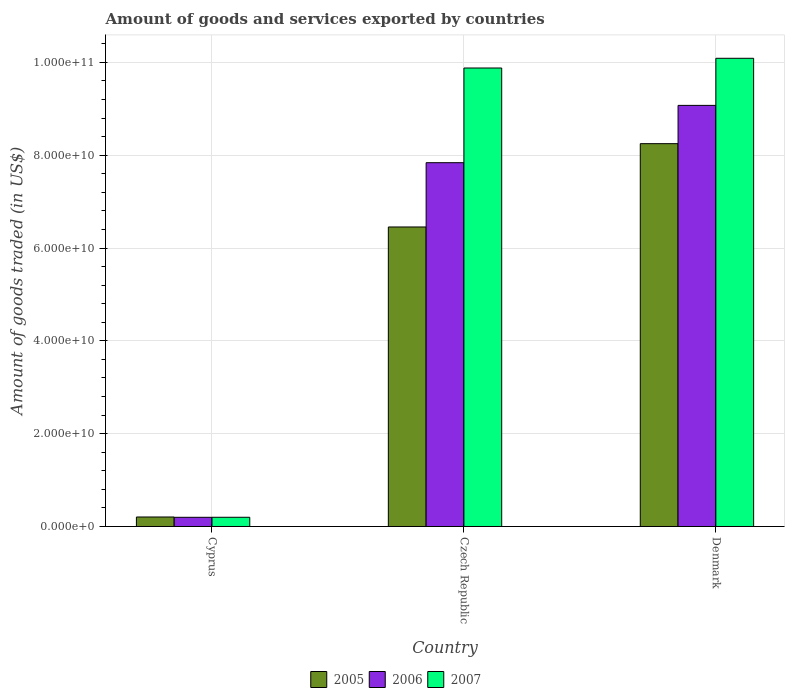How many different coloured bars are there?
Provide a succinct answer. 3. How many groups of bars are there?
Give a very brief answer. 3. Are the number of bars on each tick of the X-axis equal?
Ensure brevity in your answer.  Yes. How many bars are there on the 2nd tick from the left?
Give a very brief answer. 3. In how many cases, is the number of bars for a given country not equal to the number of legend labels?
Your answer should be very brief. 0. What is the total amount of goods and services exported in 2007 in Cyprus?
Offer a terse response. 1.99e+09. Across all countries, what is the maximum total amount of goods and services exported in 2006?
Keep it short and to the point. 9.07e+1. Across all countries, what is the minimum total amount of goods and services exported in 2006?
Provide a succinct answer. 1.98e+09. In which country was the total amount of goods and services exported in 2007 minimum?
Provide a succinct answer. Cyprus. What is the total total amount of goods and services exported in 2006 in the graph?
Offer a terse response. 1.71e+11. What is the difference between the total amount of goods and services exported in 2006 in Cyprus and that in Czech Republic?
Offer a very short reply. -7.64e+1. What is the difference between the total amount of goods and services exported in 2005 in Denmark and the total amount of goods and services exported in 2007 in Czech Republic?
Make the answer very short. -1.63e+1. What is the average total amount of goods and services exported in 2007 per country?
Your answer should be very brief. 6.72e+1. What is the difference between the total amount of goods and services exported of/in 2006 and total amount of goods and services exported of/in 2007 in Cyprus?
Provide a short and direct response. -7.27e+06. What is the ratio of the total amount of goods and services exported in 2007 in Czech Republic to that in Denmark?
Your response must be concise. 0.98. Is the difference between the total amount of goods and services exported in 2006 in Cyprus and Denmark greater than the difference between the total amount of goods and services exported in 2007 in Cyprus and Denmark?
Make the answer very short. Yes. What is the difference between the highest and the second highest total amount of goods and services exported in 2006?
Offer a terse response. -1.23e+1. What is the difference between the highest and the lowest total amount of goods and services exported in 2005?
Provide a succinct answer. 8.04e+1. Is it the case that in every country, the sum of the total amount of goods and services exported in 2006 and total amount of goods and services exported in 2007 is greater than the total amount of goods and services exported in 2005?
Keep it short and to the point. Yes. Are all the bars in the graph horizontal?
Your answer should be compact. No. What is the difference between two consecutive major ticks on the Y-axis?
Offer a very short reply. 2.00e+1. Does the graph contain any zero values?
Your answer should be very brief. No. Does the graph contain grids?
Provide a short and direct response. Yes. Where does the legend appear in the graph?
Make the answer very short. Bottom center. How many legend labels are there?
Your answer should be compact. 3. What is the title of the graph?
Your response must be concise. Amount of goods and services exported by countries. What is the label or title of the X-axis?
Offer a very short reply. Country. What is the label or title of the Y-axis?
Make the answer very short. Amount of goods traded (in US$). What is the Amount of goods traded (in US$) of 2005 in Cyprus?
Keep it short and to the point. 2.05e+09. What is the Amount of goods traded (in US$) in 2006 in Cyprus?
Offer a very short reply. 1.98e+09. What is the Amount of goods traded (in US$) in 2007 in Cyprus?
Provide a short and direct response. 1.99e+09. What is the Amount of goods traded (in US$) in 2005 in Czech Republic?
Your answer should be very brief. 6.45e+1. What is the Amount of goods traded (in US$) of 2006 in Czech Republic?
Keep it short and to the point. 7.84e+1. What is the Amount of goods traded (in US$) in 2007 in Czech Republic?
Your answer should be compact. 9.88e+1. What is the Amount of goods traded (in US$) in 2005 in Denmark?
Give a very brief answer. 8.25e+1. What is the Amount of goods traded (in US$) in 2006 in Denmark?
Make the answer very short. 9.07e+1. What is the Amount of goods traded (in US$) of 2007 in Denmark?
Offer a terse response. 1.01e+11. Across all countries, what is the maximum Amount of goods traded (in US$) in 2005?
Your answer should be very brief. 8.25e+1. Across all countries, what is the maximum Amount of goods traded (in US$) in 2006?
Your response must be concise. 9.07e+1. Across all countries, what is the maximum Amount of goods traded (in US$) in 2007?
Make the answer very short. 1.01e+11. Across all countries, what is the minimum Amount of goods traded (in US$) in 2005?
Make the answer very short. 2.05e+09. Across all countries, what is the minimum Amount of goods traded (in US$) of 2006?
Make the answer very short. 1.98e+09. Across all countries, what is the minimum Amount of goods traded (in US$) in 2007?
Offer a terse response. 1.99e+09. What is the total Amount of goods traded (in US$) in 2005 in the graph?
Offer a very short reply. 1.49e+11. What is the total Amount of goods traded (in US$) in 2006 in the graph?
Your answer should be compact. 1.71e+11. What is the total Amount of goods traded (in US$) of 2007 in the graph?
Offer a very short reply. 2.02e+11. What is the difference between the Amount of goods traded (in US$) in 2005 in Cyprus and that in Czech Republic?
Your response must be concise. -6.25e+1. What is the difference between the Amount of goods traded (in US$) in 2006 in Cyprus and that in Czech Republic?
Ensure brevity in your answer.  -7.64e+1. What is the difference between the Amount of goods traded (in US$) in 2007 in Cyprus and that in Czech Republic?
Ensure brevity in your answer.  -9.68e+1. What is the difference between the Amount of goods traded (in US$) of 2005 in Cyprus and that in Denmark?
Give a very brief answer. -8.04e+1. What is the difference between the Amount of goods traded (in US$) in 2006 in Cyprus and that in Denmark?
Make the answer very short. -8.88e+1. What is the difference between the Amount of goods traded (in US$) of 2007 in Cyprus and that in Denmark?
Make the answer very short. -9.89e+1. What is the difference between the Amount of goods traded (in US$) in 2005 in Czech Republic and that in Denmark?
Keep it short and to the point. -1.80e+1. What is the difference between the Amount of goods traded (in US$) in 2006 in Czech Republic and that in Denmark?
Offer a terse response. -1.23e+1. What is the difference between the Amount of goods traded (in US$) in 2007 in Czech Republic and that in Denmark?
Your answer should be compact. -2.09e+09. What is the difference between the Amount of goods traded (in US$) of 2005 in Cyprus and the Amount of goods traded (in US$) of 2006 in Czech Republic?
Keep it short and to the point. -7.63e+1. What is the difference between the Amount of goods traded (in US$) of 2005 in Cyprus and the Amount of goods traded (in US$) of 2007 in Czech Republic?
Keep it short and to the point. -9.67e+1. What is the difference between the Amount of goods traded (in US$) in 2006 in Cyprus and the Amount of goods traded (in US$) in 2007 in Czech Republic?
Your answer should be compact. -9.68e+1. What is the difference between the Amount of goods traded (in US$) in 2005 in Cyprus and the Amount of goods traded (in US$) in 2006 in Denmark?
Provide a succinct answer. -8.87e+1. What is the difference between the Amount of goods traded (in US$) of 2005 in Cyprus and the Amount of goods traded (in US$) of 2007 in Denmark?
Offer a very short reply. -9.88e+1. What is the difference between the Amount of goods traded (in US$) of 2006 in Cyprus and the Amount of goods traded (in US$) of 2007 in Denmark?
Offer a very short reply. -9.89e+1. What is the difference between the Amount of goods traded (in US$) of 2005 in Czech Republic and the Amount of goods traded (in US$) of 2006 in Denmark?
Ensure brevity in your answer.  -2.62e+1. What is the difference between the Amount of goods traded (in US$) in 2005 in Czech Republic and the Amount of goods traded (in US$) in 2007 in Denmark?
Ensure brevity in your answer.  -3.63e+1. What is the difference between the Amount of goods traded (in US$) in 2006 in Czech Republic and the Amount of goods traded (in US$) in 2007 in Denmark?
Your answer should be compact. -2.25e+1. What is the average Amount of goods traded (in US$) of 2005 per country?
Provide a short and direct response. 4.97e+1. What is the average Amount of goods traded (in US$) of 2006 per country?
Your answer should be very brief. 5.70e+1. What is the average Amount of goods traded (in US$) of 2007 per country?
Offer a very short reply. 6.72e+1. What is the difference between the Amount of goods traded (in US$) of 2005 and Amount of goods traded (in US$) of 2006 in Cyprus?
Keep it short and to the point. 6.64e+07. What is the difference between the Amount of goods traded (in US$) in 2005 and Amount of goods traded (in US$) in 2007 in Cyprus?
Provide a short and direct response. 5.92e+07. What is the difference between the Amount of goods traded (in US$) of 2006 and Amount of goods traded (in US$) of 2007 in Cyprus?
Make the answer very short. -7.27e+06. What is the difference between the Amount of goods traded (in US$) of 2005 and Amount of goods traded (in US$) of 2006 in Czech Republic?
Your response must be concise. -1.38e+1. What is the difference between the Amount of goods traded (in US$) in 2005 and Amount of goods traded (in US$) in 2007 in Czech Republic?
Offer a very short reply. -3.43e+1. What is the difference between the Amount of goods traded (in US$) in 2006 and Amount of goods traded (in US$) in 2007 in Czech Republic?
Your response must be concise. -2.04e+1. What is the difference between the Amount of goods traded (in US$) of 2005 and Amount of goods traded (in US$) of 2006 in Denmark?
Offer a terse response. -8.25e+09. What is the difference between the Amount of goods traded (in US$) of 2005 and Amount of goods traded (in US$) of 2007 in Denmark?
Offer a terse response. -1.84e+1. What is the difference between the Amount of goods traded (in US$) of 2006 and Amount of goods traded (in US$) of 2007 in Denmark?
Offer a very short reply. -1.01e+1. What is the ratio of the Amount of goods traded (in US$) of 2005 in Cyprus to that in Czech Republic?
Provide a succinct answer. 0.03. What is the ratio of the Amount of goods traded (in US$) of 2006 in Cyprus to that in Czech Republic?
Offer a terse response. 0.03. What is the ratio of the Amount of goods traded (in US$) in 2007 in Cyprus to that in Czech Republic?
Provide a succinct answer. 0.02. What is the ratio of the Amount of goods traded (in US$) of 2005 in Cyprus to that in Denmark?
Your answer should be compact. 0.02. What is the ratio of the Amount of goods traded (in US$) of 2006 in Cyprus to that in Denmark?
Provide a succinct answer. 0.02. What is the ratio of the Amount of goods traded (in US$) of 2007 in Cyprus to that in Denmark?
Your response must be concise. 0.02. What is the ratio of the Amount of goods traded (in US$) of 2005 in Czech Republic to that in Denmark?
Your response must be concise. 0.78. What is the ratio of the Amount of goods traded (in US$) in 2006 in Czech Republic to that in Denmark?
Your response must be concise. 0.86. What is the ratio of the Amount of goods traded (in US$) of 2007 in Czech Republic to that in Denmark?
Your response must be concise. 0.98. What is the difference between the highest and the second highest Amount of goods traded (in US$) in 2005?
Offer a very short reply. 1.80e+1. What is the difference between the highest and the second highest Amount of goods traded (in US$) in 2006?
Offer a very short reply. 1.23e+1. What is the difference between the highest and the second highest Amount of goods traded (in US$) in 2007?
Make the answer very short. 2.09e+09. What is the difference between the highest and the lowest Amount of goods traded (in US$) in 2005?
Your answer should be very brief. 8.04e+1. What is the difference between the highest and the lowest Amount of goods traded (in US$) of 2006?
Give a very brief answer. 8.88e+1. What is the difference between the highest and the lowest Amount of goods traded (in US$) in 2007?
Offer a terse response. 9.89e+1. 